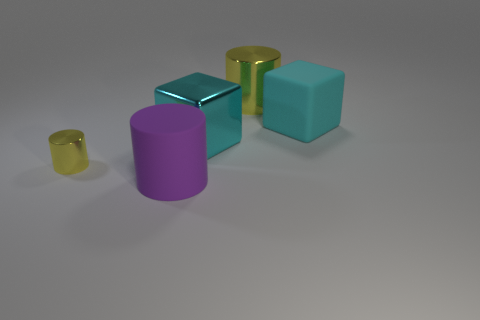Imagine if these objects were in a video game, what could their purpose be? If these objects were in a video game, they could serve a variety of purposes. The different materials and colors suggest they might be collectibles or resources the player must gather. The cylinders could be containers or power-up units, while the cubes might be building blocks for structures or puzzle elements that unlock new game levels. 